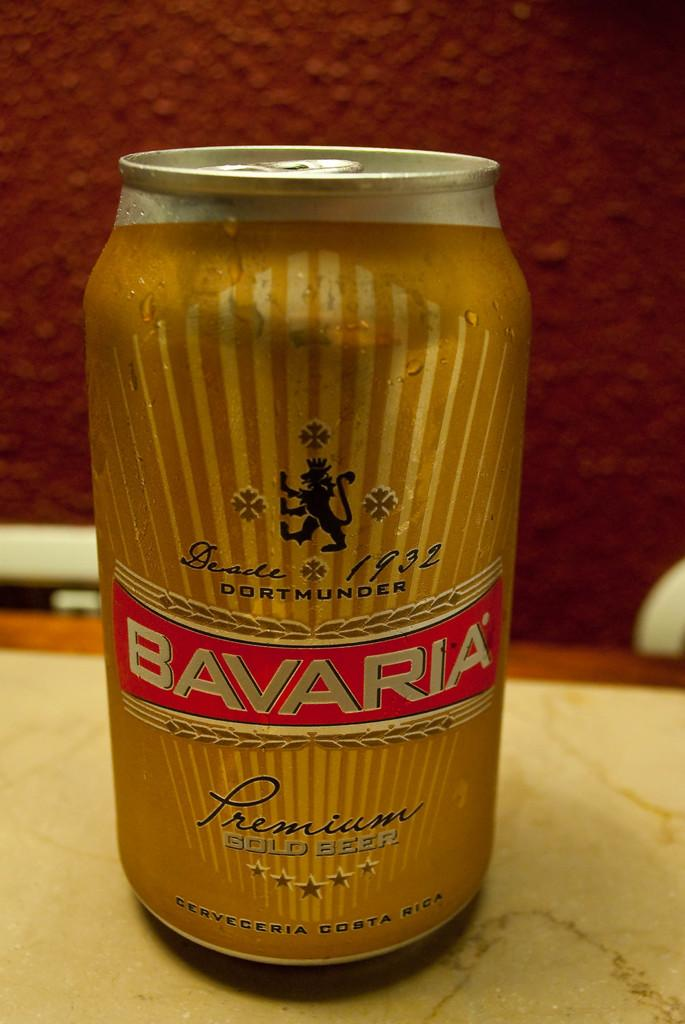<image>
Relay a brief, clear account of the picture shown. A can of Bavaria beer is shown against a red wall. 